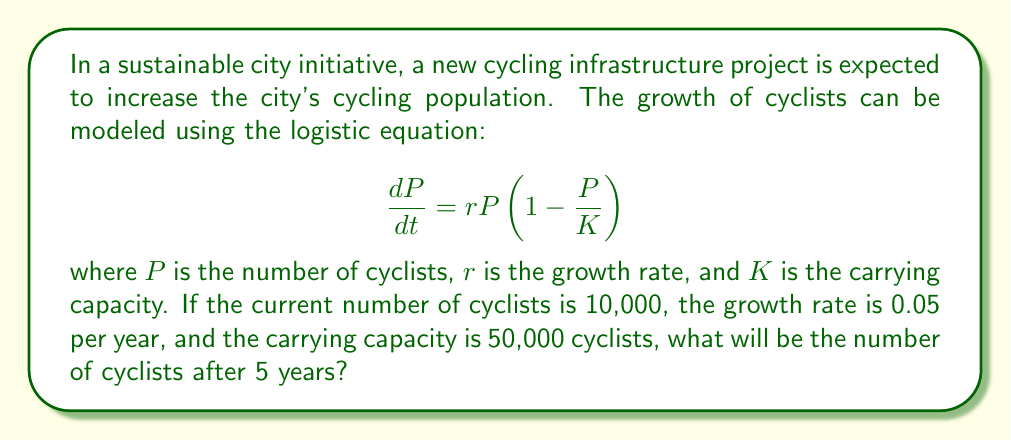Can you solve this math problem? To solve this problem, we'll use the logistic growth equation solution:

$$P(t) = \frac{KP_0e^{rt}}{K + P_0(e^{rt} - 1)}$$

Where:
$P(t)$ is the population at time $t$
$K$ is the carrying capacity (50,000)
$P_0$ is the initial population (10,000)
$r$ is the growth rate (0.05)
$t$ is the time in years (5)

Let's substitute these values:

$$P(5) = \frac{50000 \cdot 10000 \cdot e^{0.05 \cdot 5}}{50000 + 10000(e^{0.05 \cdot 5} - 1)}$$

Now, let's calculate step by step:

1. Calculate $e^{0.05 \cdot 5}$:
   $e^{0.25} \approx 1.2840$

2. Substitute this value:
   $$P(5) = \frac{50000 \cdot 10000 \cdot 1.2840}{50000 + 10000(1.2840 - 1)}$$

3. Simplify:
   $$P(5) = \frac{642000000}{50000 + 2840} = \frac{642000000}{52840}$$

4. Calculate the final result:
   $P(5) \approx 12149.32$

5. Round to the nearest whole number:
   $P(5) \approx 12149$ cyclists
Answer: 12149 cyclists 